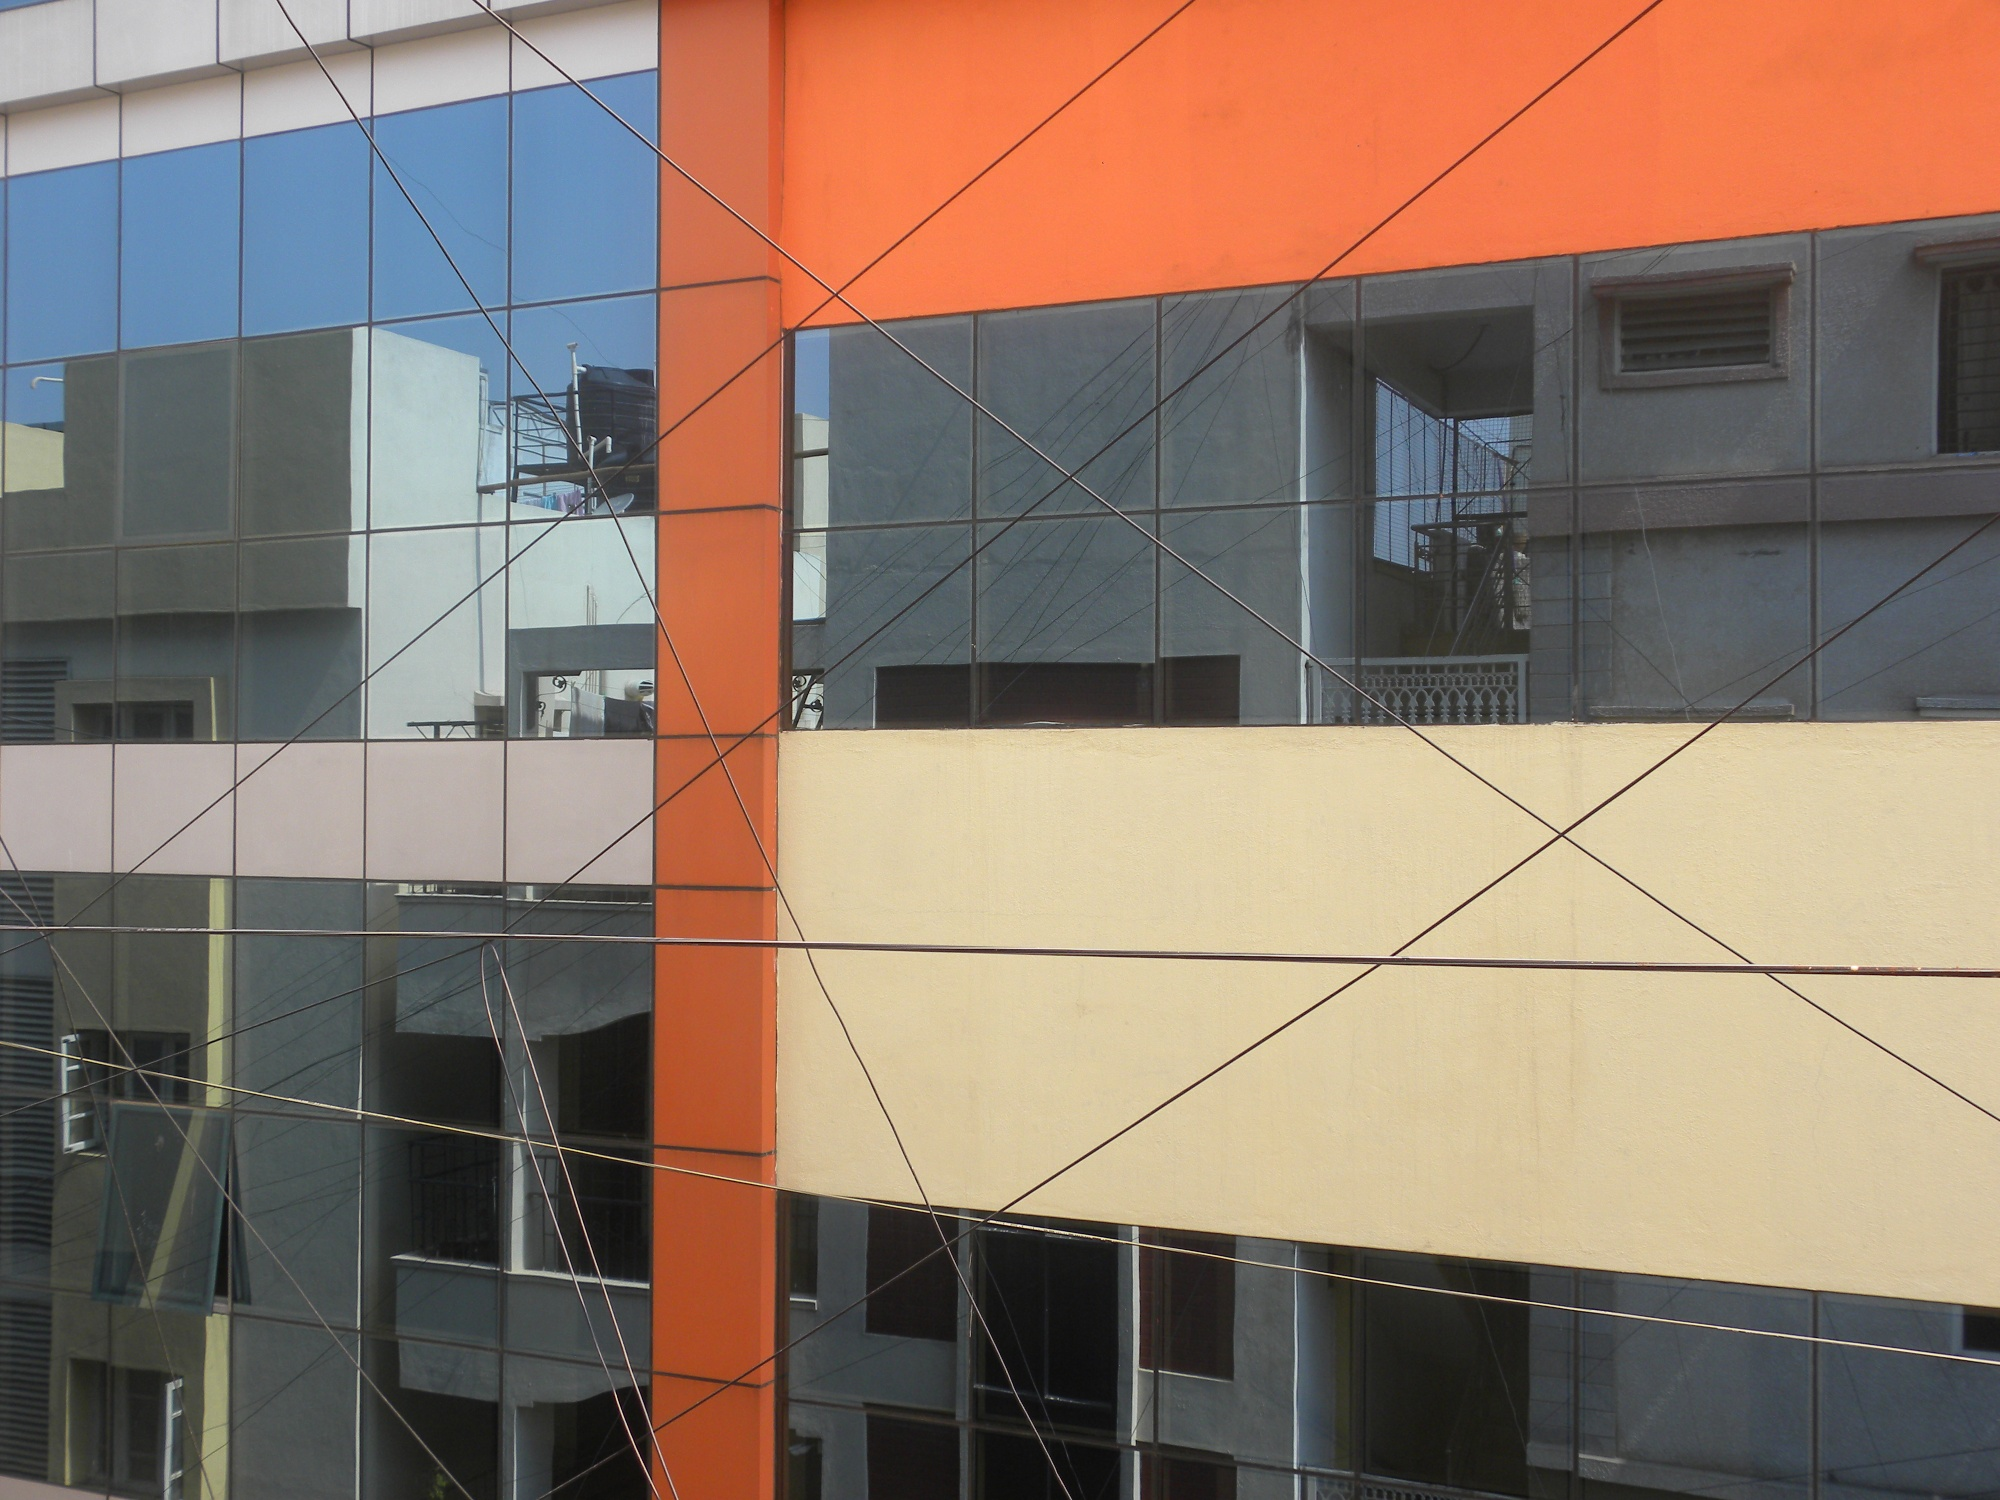Can you describe the significance of the color scheme in this building's design? The color scheme of the building, consisting of bright orange, muted gray, and soft beige, creates a visually striking and appealing design. The vibrant orange adds a sense of energy and modernity, catching the viewer’s attention, while the gray and beige tones provide a neutral balance, enhancing the overall aesthetic harmony. This combination not only reflects a contemporary architectural approach but also potentially symbolizes a blend of innovation (orange) with stability (gray and beige). 